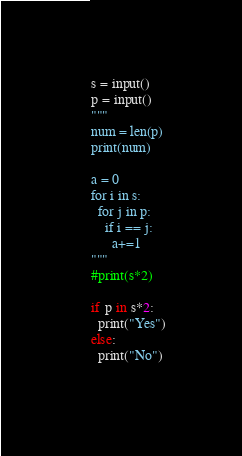Convert code to text. <code><loc_0><loc_0><loc_500><loc_500><_Python_>s = input()
p = input()
"""
num = len(p)
print(num)

a = 0
for i in s:
  for j in p:
    if i == j:
      a+=1
"""
#print(s*2)
      
if p in s*2:
  print("Yes")
else:
  print("No")
    
</code> 